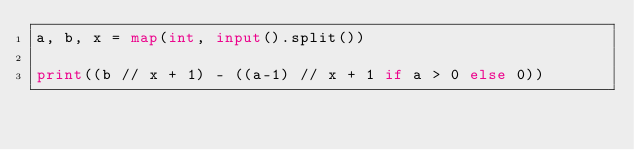Convert code to text. <code><loc_0><loc_0><loc_500><loc_500><_Python_>a, b, x = map(int, input().split())

print((b // x + 1) - ((a-1) // x + 1 if a > 0 else 0))
</code> 